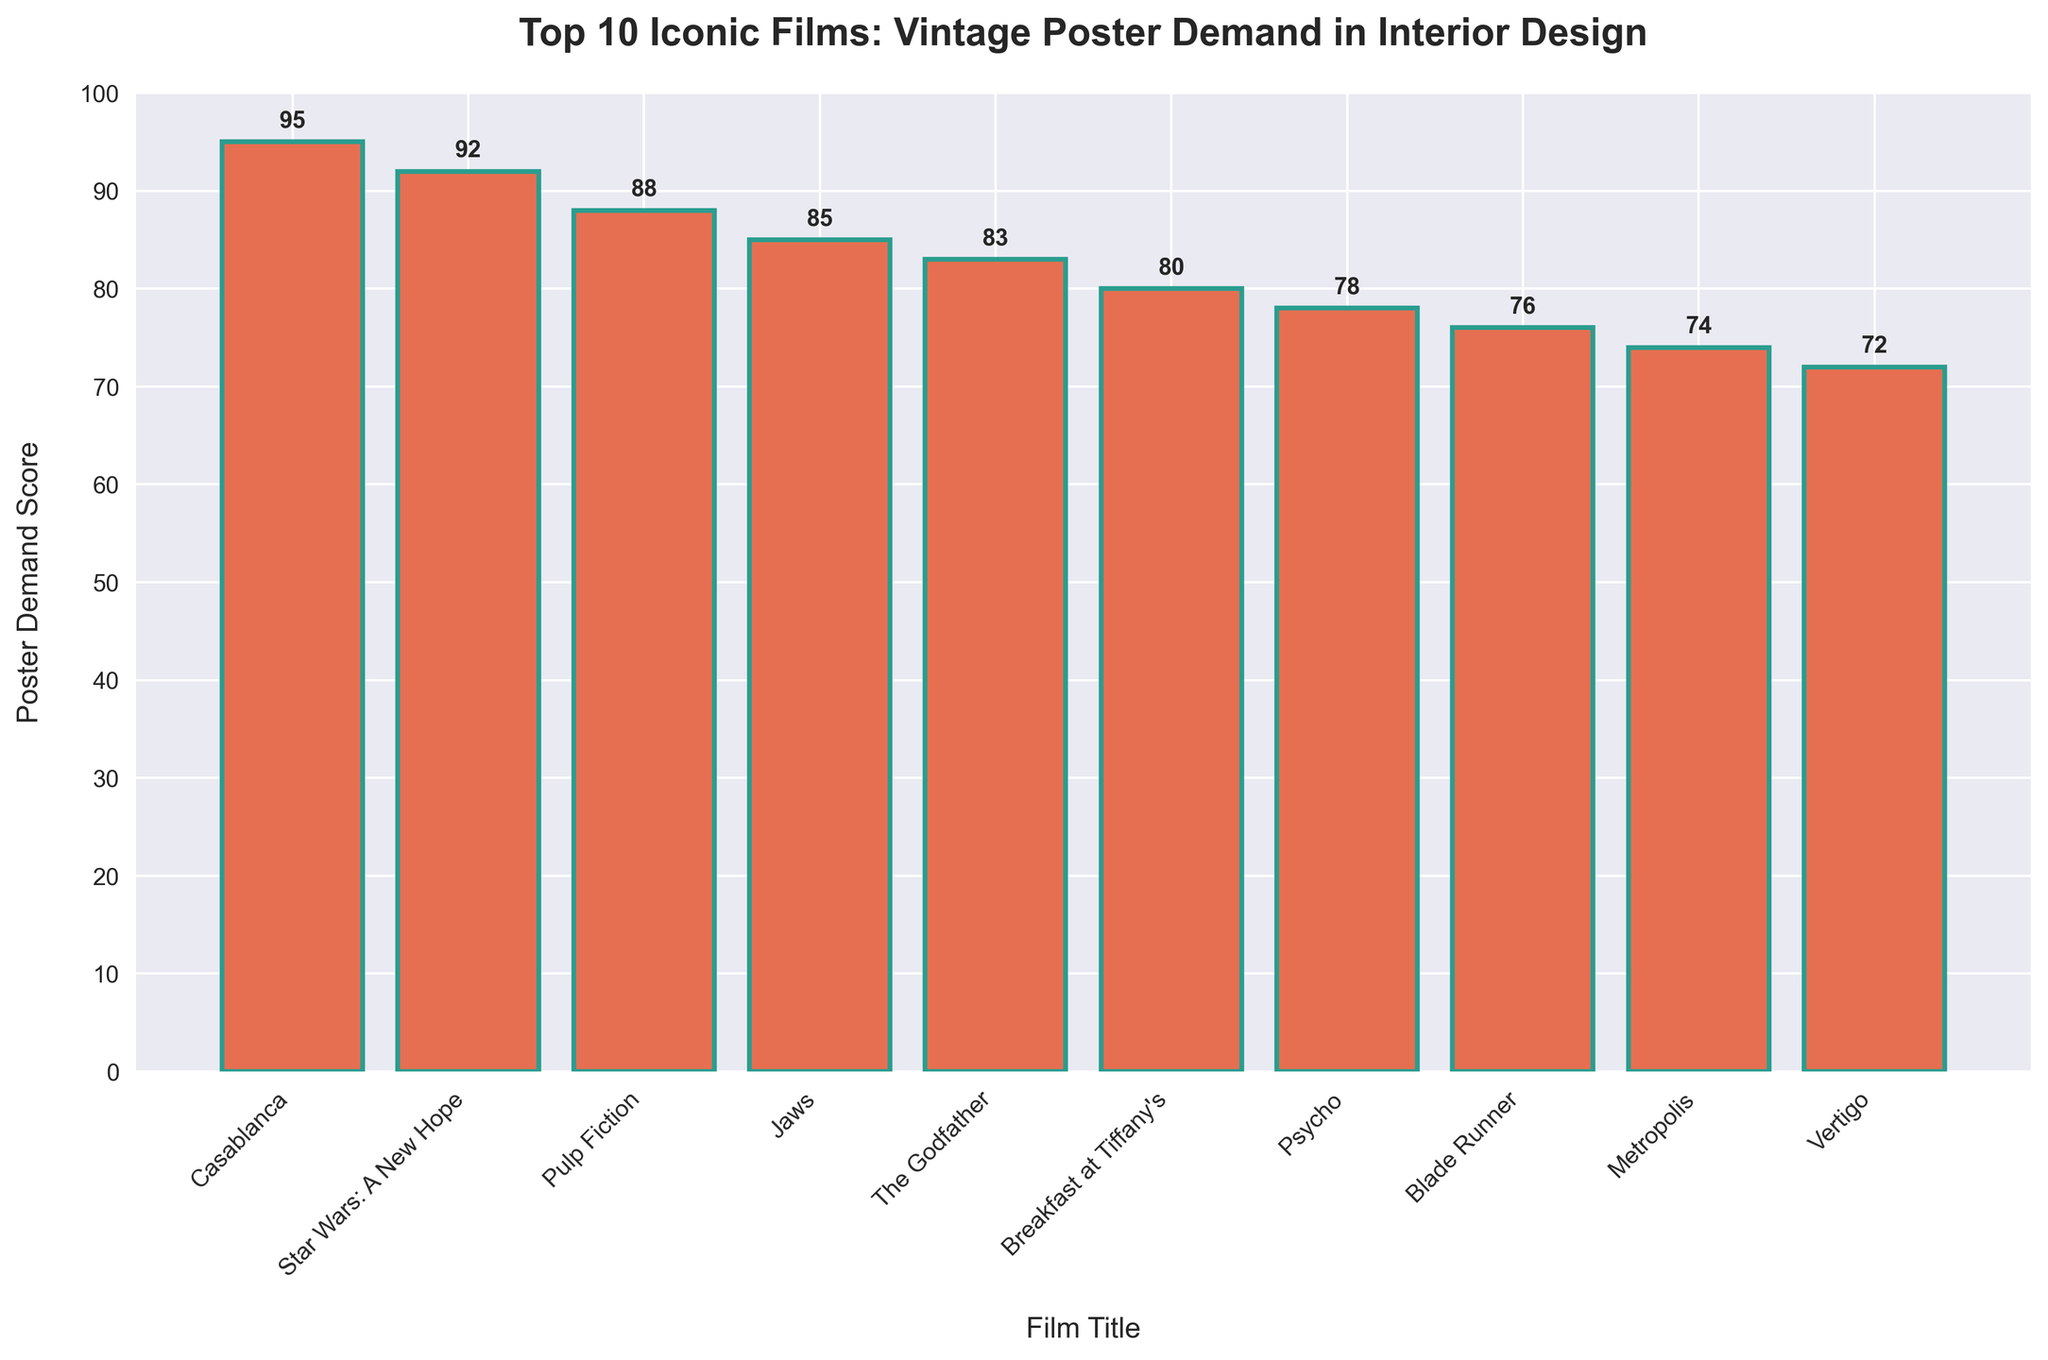Which film has the highest poster demand score? The film with the highest bar represents the highest poster demand score. The tallest bar corresponds to "Casablanca" with a score of 95.
Answer: Casablanca Which film has the lowest poster demand score? The film with the lowest bar represents the lowest poster demand score. The shortest bar corresponds to "Vertigo" with a score of 72.
Answer: Vertigo How much higher is the poster demand score of "Casablanca" compared to "Vertigo"? Subtract the score of "Vertigo" from the score of "Casablanca". 95 - 72 = 23
Answer: 23 What is the average poster demand score of the top 3 films? Sum the scores of the top 3 films and divide by 3. (95 + 92 + 88) / 3 = 91.67
Answer: 91.67 Which films have a poster demand score greater than 80? The bars that extend above the 80 mark on the y-axis represent films with scores greater than 80. These are "Casablanca", "Star Wars: A New Hope", "Pulp Fiction", "Jaws", and "The Godfather".
Answer: Casablanca, Star Wars: A New Hope, Pulp Fiction, Jaws, The Godfather What is the combined poster demand score of "Psycho" and "Blade Runner"? Add the scores of "Psycho" and "Blade Runner". 78 + 76 = 154
Answer: 154 Which film has a poster demand score closest to 80? Find the bar that is closest to the 80 mark on the y-axis. "Breakfast at Tiffany's" has a score of 80.
Answer: Breakfast at Tiffany's How many films have a poster demand score below 75? Count the number of bars that do not exceed the 75 mark on the y-axis. These are "Metropolis" and "Vertigo". There are 2 films.
Answer: 2 By how many points is the demand score of "Star Wars: A New Hope" greater than "Jaws"? Subtract the score of "Jaws" from the score of "Star Wars: A New Hope". 92 - 85 = 7
Answer: 7 What is the total poster demand score of all the films combined? Sum the scores of all 10 films. 95 + 92 + 88 + 85 + 83 + 80 + 78 + 76 + 74 + 72 = 823
Answer: 823 